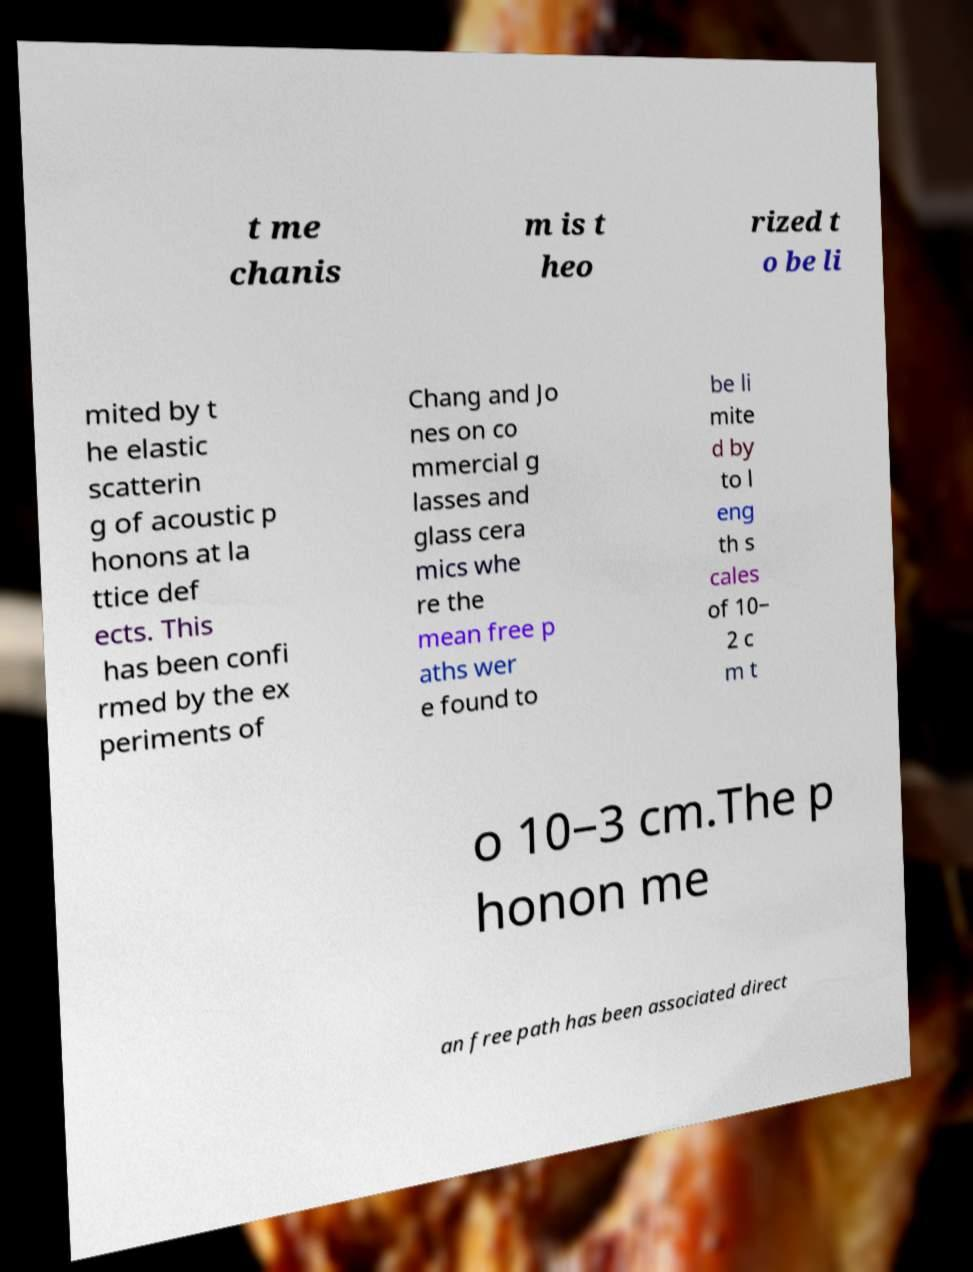Please read and relay the text visible in this image. What does it say? t me chanis m is t heo rized t o be li mited by t he elastic scatterin g of acoustic p honons at la ttice def ects. This has been confi rmed by the ex periments of Chang and Jo nes on co mmercial g lasses and glass cera mics whe re the mean free p aths wer e found to be li mite d by to l eng th s cales of 10− 2 c m t o 10−3 cm.The p honon me an free path has been associated direct 